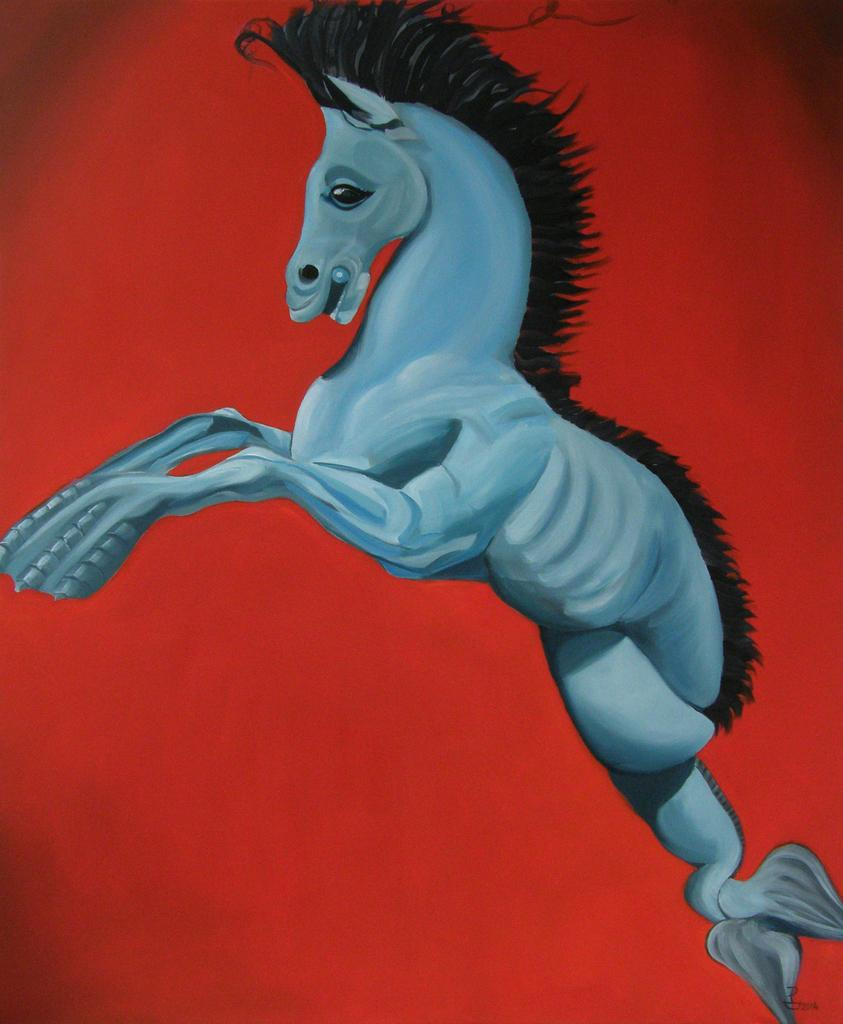What is the main subject of the image? The main subject of the image is an art of a horse. What color is the background of the image? The background of the image is red in color. What type of exchange is taking place between the horse and the slave in the image? There is no exchange or slave present in the image; it only contains an art of a horse with a red background. 